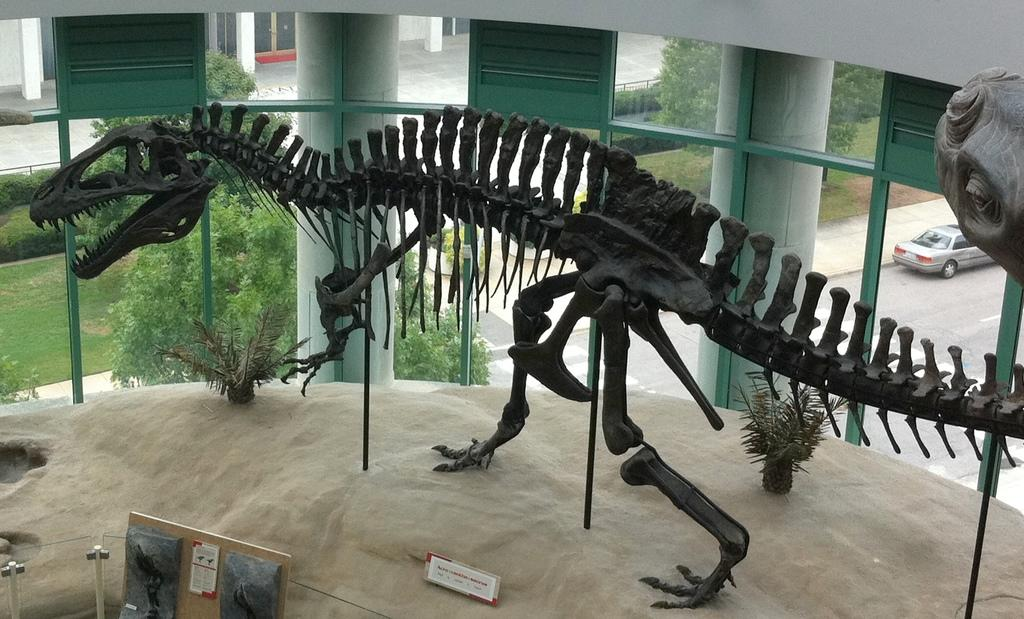What is the main subject of the image? There is a dinosaur skeleton on the floor in the image. What can be seen in the background of the image? There is a car on the road and trees in the background of the image. Where was the image taken? The image was taken inside a museum. What type of insect can be seen crawling on the dinosaur skeleton in the image? There are no insects visible on the dinosaur skeleton in the image. What type of meat is being served in the museum's cafe, as seen in the image? There is no cafe or any food visible in the image; it only shows a dinosaur skeleton and the background. 